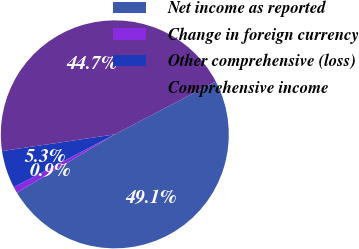Convert chart to OTSL. <chart><loc_0><loc_0><loc_500><loc_500><pie_chart><fcel>Net income as reported<fcel>Change in foreign currency<fcel>Other comprehensive (loss)<fcel>Comprehensive income<nl><fcel>49.13%<fcel>0.87%<fcel>5.33%<fcel>44.67%<nl></chart> 